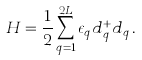Convert formula to latex. <formula><loc_0><loc_0><loc_500><loc_500>H = \frac { 1 } { 2 } \sum _ { q = 1 } ^ { 2 L } \epsilon _ { q } d _ { q } ^ { + } d _ { q } \, .</formula> 